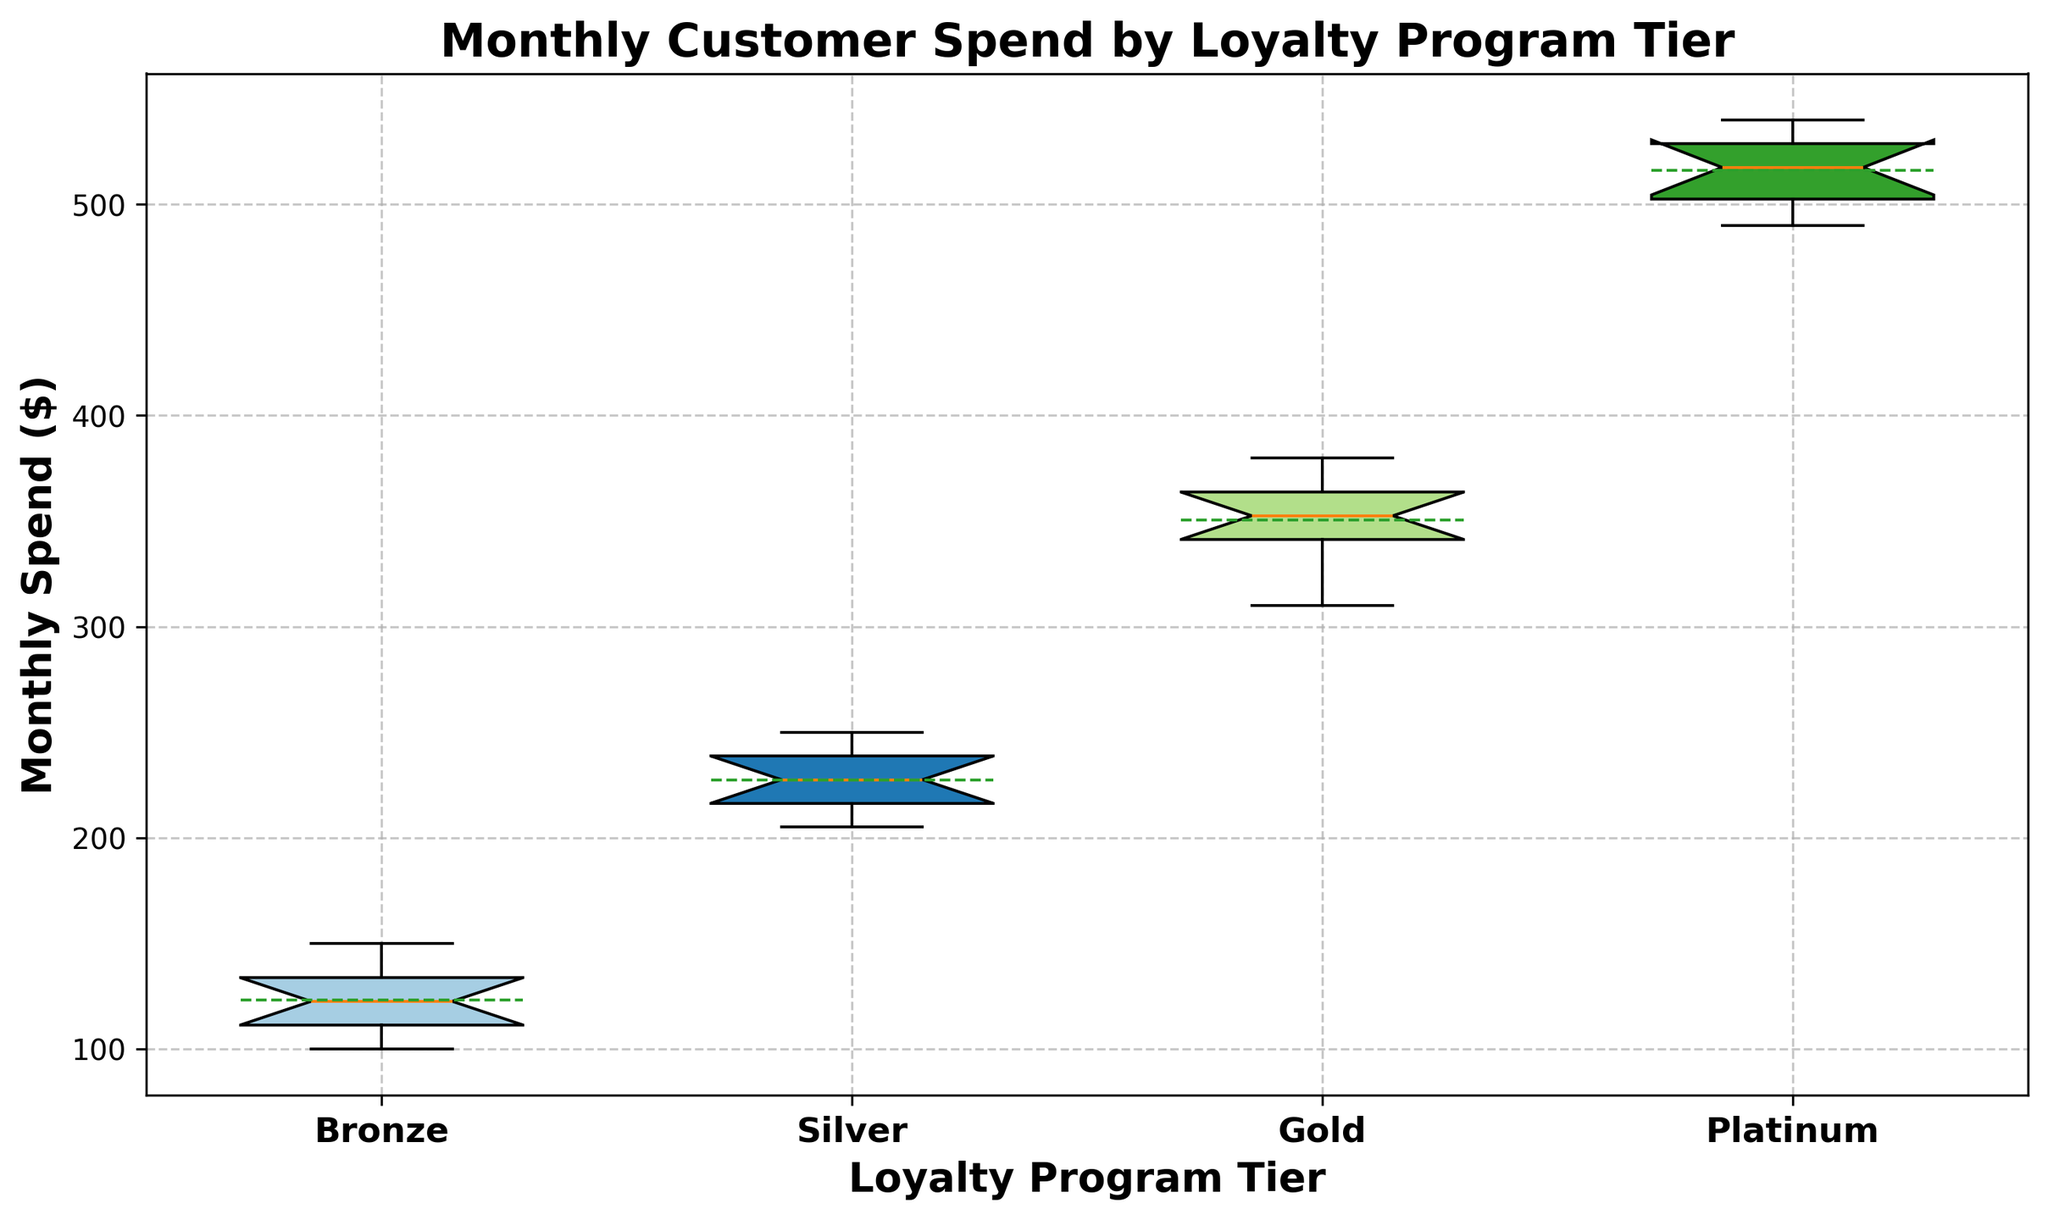Which tier has the highest median monthly spend? To find the highest median, first identify the median lines inside the boxes of each tier. The tier with the highest median line is Platinum.
Answer: Platinum How much higher is the mean monthly spend in the Platinum tier compared to the Bronze tier? Examine the mean lines in the boxes. The mean for Platinum is approximately 517.5 and for Bronze is around 122.5. 517.5 - 122.5 = 395.
Answer: 395 What is the interquartile range (IQR) of the Silver tier? The IQR is the difference between the third quartile (Q3) and the first quartile (Q1). For Silver, Q3 is around 240, and Q1 is about 210. So, 240 - 210 = 30.
Answer: 30 Which loyalty tier shows the greatest variability in monthly spend? Variability can be assessed by the length of the box (IQR) and the overall spread (including whiskers). The Platinum tier shows the greatest spread, indicating the highest variability.
Answer: Platinum Is there any overlap in the monthly spend ranges between the Silver and Gold tiers? Look for any overlap between the whiskers and the interquartile ranges of these two tiers. The maximum spend in the Silver tier does not overlap with the minimum spend in the Gold tier. Therefore, there is no overlap.
Answer: No Among all tiers, which one has the smallest range of monthly spend (difference between maximum and minimum values)? Compare the range (whisker-to-whisker distance) for each tier. The Bronze tier has the smallest range.
Answer: Bronze What is the general trend in monthly spend as we move from Bronze to Platinum tiers? Observe the general tendency of the medians and means across the tiers. The trend shows an increase in both measures as we move from Bronze to Platinum.
Answer: Increase How does the mean monthly spend in the Silver tier compare to the median monthly spend in the Gold tier? Identify the mean line for Silver (approximately 232.5) and compare it to the median line for Gold (about 352.5). The mean for Silver is significantly lower than the median for Gold.
Answer: Lower In which tier is the mean closest to the median monthly spend? Compare the distances between mean and median lines within each box. For Bronze, the mean and median are very close to each other.
Answer: Bronze 